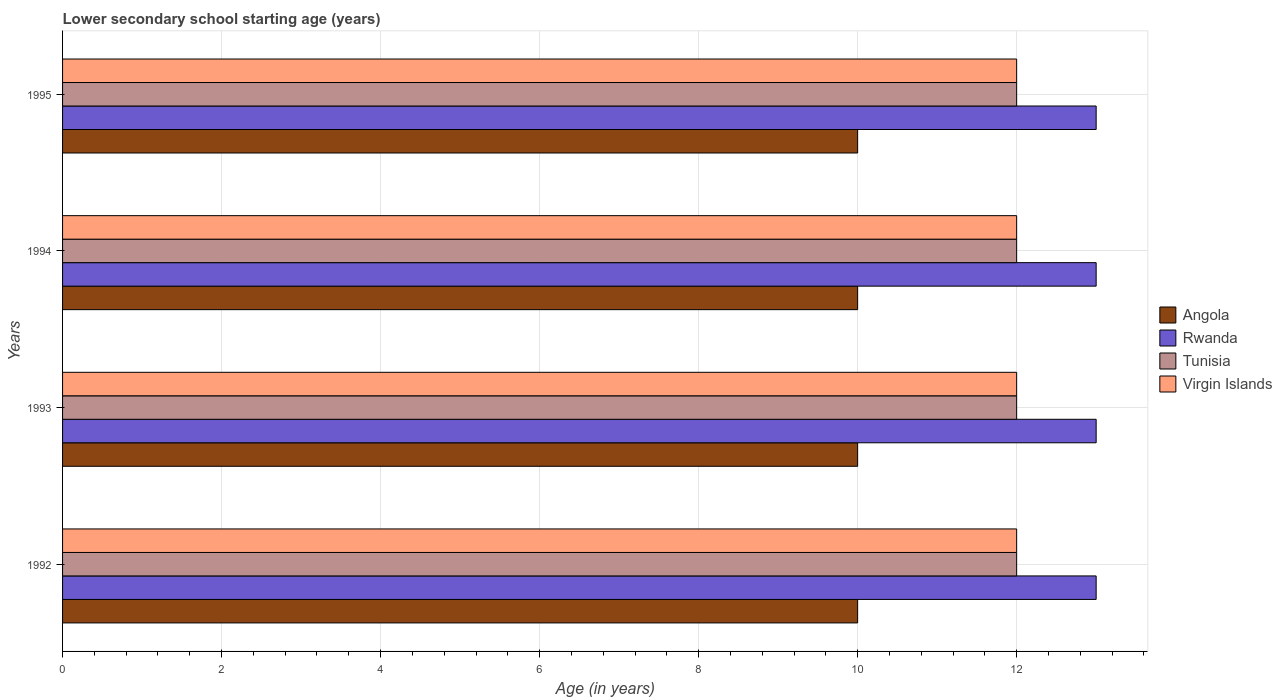How many groups of bars are there?
Your answer should be very brief. 4. How many bars are there on the 4th tick from the top?
Keep it short and to the point. 4. How many bars are there on the 4th tick from the bottom?
Your answer should be compact. 4. What is the lower secondary school starting age of children in Tunisia in 1992?
Keep it short and to the point. 12. Across all years, what is the maximum lower secondary school starting age of children in Tunisia?
Give a very brief answer. 12. In which year was the lower secondary school starting age of children in Virgin Islands minimum?
Provide a succinct answer. 1992. What is the total lower secondary school starting age of children in Angola in the graph?
Provide a succinct answer. 40. What is the difference between the lower secondary school starting age of children in Tunisia in 1994 and that in 1995?
Your response must be concise. 0. What is the average lower secondary school starting age of children in Angola per year?
Your response must be concise. 10. In the year 1994, what is the difference between the lower secondary school starting age of children in Tunisia and lower secondary school starting age of children in Virgin Islands?
Ensure brevity in your answer.  0. What is the ratio of the lower secondary school starting age of children in Tunisia in 1992 to that in 1994?
Offer a very short reply. 1. In how many years, is the lower secondary school starting age of children in Rwanda greater than the average lower secondary school starting age of children in Rwanda taken over all years?
Provide a short and direct response. 0. Is it the case that in every year, the sum of the lower secondary school starting age of children in Virgin Islands and lower secondary school starting age of children in Angola is greater than the sum of lower secondary school starting age of children in Tunisia and lower secondary school starting age of children in Rwanda?
Give a very brief answer. No. What does the 2nd bar from the top in 1995 represents?
Make the answer very short. Tunisia. What does the 2nd bar from the bottom in 1992 represents?
Ensure brevity in your answer.  Rwanda. How many bars are there?
Your response must be concise. 16. What is the difference between two consecutive major ticks on the X-axis?
Keep it short and to the point. 2. Are the values on the major ticks of X-axis written in scientific E-notation?
Make the answer very short. No. Does the graph contain grids?
Give a very brief answer. Yes. How many legend labels are there?
Provide a short and direct response. 4. What is the title of the graph?
Offer a very short reply. Lower secondary school starting age (years). What is the label or title of the X-axis?
Offer a terse response. Age (in years). What is the label or title of the Y-axis?
Keep it short and to the point. Years. What is the Age (in years) of Angola in 1992?
Your answer should be very brief. 10. What is the Age (in years) in Tunisia in 1992?
Provide a succinct answer. 12. What is the Age (in years) of Rwanda in 1994?
Provide a short and direct response. 13. What is the Age (in years) of Virgin Islands in 1995?
Ensure brevity in your answer.  12. Across all years, what is the maximum Age (in years) of Rwanda?
Your answer should be compact. 13. Across all years, what is the maximum Age (in years) of Tunisia?
Your response must be concise. 12. Across all years, what is the maximum Age (in years) in Virgin Islands?
Provide a short and direct response. 12. Across all years, what is the minimum Age (in years) of Rwanda?
Your answer should be very brief. 13. Across all years, what is the minimum Age (in years) in Tunisia?
Offer a very short reply. 12. What is the total Age (in years) of Rwanda in the graph?
Give a very brief answer. 52. What is the difference between the Age (in years) in Rwanda in 1992 and that in 1993?
Offer a very short reply. 0. What is the difference between the Age (in years) of Rwanda in 1992 and that in 1994?
Offer a terse response. 0. What is the difference between the Age (in years) of Tunisia in 1992 and that in 1994?
Your answer should be compact. 0. What is the difference between the Age (in years) of Virgin Islands in 1992 and that in 1995?
Provide a short and direct response. 0. What is the difference between the Age (in years) in Tunisia in 1993 and that in 1994?
Ensure brevity in your answer.  0. What is the difference between the Age (in years) of Virgin Islands in 1993 and that in 1994?
Make the answer very short. 0. What is the difference between the Age (in years) in Angola in 1993 and that in 1995?
Keep it short and to the point. 0. What is the difference between the Age (in years) of Tunisia in 1993 and that in 1995?
Make the answer very short. 0. What is the difference between the Age (in years) in Virgin Islands in 1993 and that in 1995?
Provide a short and direct response. 0. What is the difference between the Age (in years) in Angola in 1994 and that in 1995?
Provide a short and direct response. 0. What is the difference between the Age (in years) of Virgin Islands in 1994 and that in 1995?
Ensure brevity in your answer.  0. What is the difference between the Age (in years) in Angola in 1992 and the Age (in years) in Tunisia in 1993?
Make the answer very short. -2. What is the difference between the Age (in years) of Rwanda in 1992 and the Age (in years) of Virgin Islands in 1993?
Make the answer very short. 1. What is the difference between the Age (in years) of Tunisia in 1992 and the Age (in years) of Virgin Islands in 1993?
Ensure brevity in your answer.  0. What is the difference between the Age (in years) in Angola in 1992 and the Age (in years) in Rwanda in 1994?
Provide a succinct answer. -3. What is the difference between the Age (in years) of Angola in 1992 and the Age (in years) of Virgin Islands in 1994?
Give a very brief answer. -2. What is the difference between the Age (in years) in Rwanda in 1992 and the Age (in years) in Virgin Islands in 1994?
Provide a succinct answer. 1. What is the difference between the Age (in years) of Angola in 1992 and the Age (in years) of Virgin Islands in 1995?
Keep it short and to the point. -2. What is the difference between the Age (in years) in Rwanda in 1992 and the Age (in years) in Virgin Islands in 1995?
Make the answer very short. 1. What is the difference between the Age (in years) of Tunisia in 1992 and the Age (in years) of Virgin Islands in 1995?
Ensure brevity in your answer.  0. What is the difference between the Age (in years) of Rwanda in 1993 and the Age (in years) of Tunisia in 1994?
Offer a terse response. 1. What is the difference between the Age (in years) in Rwanda in 1993 and the Age (in years) in Virgin Islands in 1994?
Offer a terse response. 1. What is the difference between the Age (in years) of Angola in 1993 and the Age (in years) of Rwanda in 1995?
Provide a short and direct response. -3. What is the difference between the Age (in years) in Tunisia in 1993 and the Age (in years) in Virgin Islands in 1995?
Ensure brevity in your answer.  0. What is the difference between the Age (in years) of Angola in 1994 and the Age (in years) of Virgin Islands in 1995?
Your answer should be compact. -2. What is the difference between the Age (in years) in Rwanda in 1994 and the Age (in years) in Tunisia in 1995?
Offer a terse response. 1. What is the difference between the Age (in years) in Tunisia in 1994 and the Age (in years) in Virgin Islands in 1995?
Make the answer very short. 0. What is the average Age (in years) of Rwanda per year?
Provide a succinct answer. 13. What is the average Age (in years) of Tunisia per year?
Keep it short and to the point. 12. In the year 1992, what is the difference between the Age (in years) in Angola and Age (in years) in Tunisia?
Keep it short and to the point. -2. In the year 1992, what is the difference between the Age (in years) of Rwanda and Age (in years) of Tunisia?
Ensure brevity in your answer.  1. In the year 1993, what is the difference between the Age (in years) in Angola and Age (in years) in Virgin Islands?
Your answer should be compact. -2. In the year 1993, what is the difference between the Age (in years) in Rwanda and Age (in years) in Tunisia?
Ensure brevity in your answer.  1. In the year 1993, what is the difference between the Age (in years) in Rwanda and Age (in years) in Virgin Islands?
Make the answer very short. 1. In the year 1994, what is the difference between the Age (in years) in Angola and Age (in years) in Tunisia?
Keep it short and to the point. -2. In the year 1994, what is the difference between the Age (in years) of Rwanda and Age (in years) of Virgin Islands?
Your answer should be compact. 1. In the year 1994, what is the difference between the Age (in years) of Tunisia and Age (in years) of Virgin Islands?
Provide a short and direct response. 0. In the year 1995, what is the difference between the Age (in years) in Angola and Age (in years) in Virgin Islands?
Your response must be concise. -2. In the year 1995, what is the difference between the Age (in years) in Rwanda and Age (in years) in Virgin Islands?
Make the answer very short. 1. In the year 1995, what is the difference between the Age (in years) in Tunisia and Age (in years) in Virgin Islands?
Give a very brief answer. 0. What is the ratio of the Age (in years) of Rwanda in 1992 to that in 1994?
Your answer should be compact. 1. What is the ratio of the Age (in years) in Angola in 1992 to that in 1995?
Offer a terse response. 1. What is the ratio of the Age (in years) of Tunisia in 1992 to that in 1995?
Provide a short and direct response. 1. What is the ratio of the Age (in years) of Virgin Islands in 1992 to that in 1995?
Your response must be concise. 1. What is the ratio of the Age (in years) of Rwanda in 1993 to that in 1994?
Your answer should be very brief. 1. What is the ratio of the Age (in years) in Tunisia in 1993 to that in 1994?
Your response must be concise. 1. What is the ratio of the Age (in years) of Virgin Islands in 1993 to that in 1994?
Provide a succinct answer. 1. What is the ratio of the Age (in years) in Angola in 1993 to that in 1995?
Ensure brevity in your answer.  1. What is the ratio of the Age (in years) of Rwanda in 1993 to that in 1995?
Provide a short and direct response. 1. What is the ratio of the Age (in years) of Tunisia in 1993 to that in 1995?
Provide a succinct answer. 1. What is the ratio of the Age (in years) in Tunisia in 1994 to that in 1995?
Ensure brevity in your answer.  1. What is the ratio of the Age (in years) in Virgin Islands in 1994 to that in 1995?
Provide a succinct answer. 1. What is the difference between the highest and the second highest Age (in years) in Angola?
Offer a very short reply. 0. What is the difference between the highest and the second highest Age (in years) of Tunisia?
Your answer should be very brief. 0. What is the difference between the highest and the lowest Age (in years) in Angola?
Your response must be concise. 0. What is the difference between the highest and the lowest Age (in years) in Rwanda?
Ensure brevity in your answer.  0. What is the difference between the highest and the lowest Age (in years) of Tunisia?
Keep it short and to the point. 0. What is the difference between the highest and the lowest Age (in years) of Virgin Islands?
Your answer should be very brief. 0. 